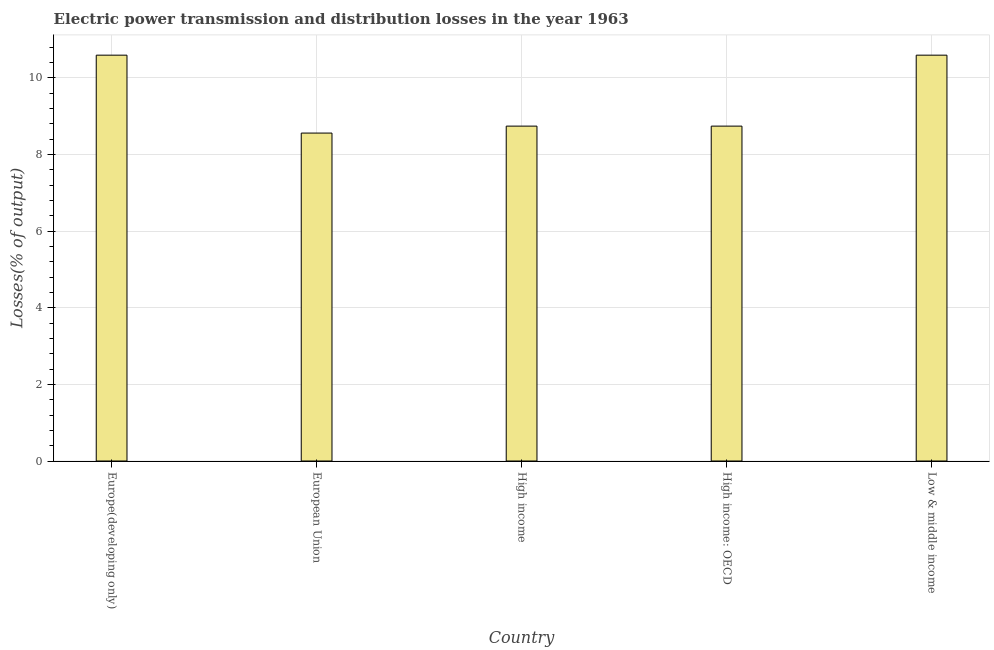Does the graph contain any zero values?
Your answer should be very brief. No. What is the title of the graph?
Provide a short and direct response. Electric power transmission and distribution losses in the year 1963. What is the label or title of the X-axis?
Offer a terse response. Country. What is the label or title of the Y-axis?
Your response must be concise. Losses(% of output). What is the electric power transmission and distribution losses in Low & middle income?
Provide a short and direct response. 10.6. Across all countries, what is the maximum electric power transmission and distribution losses?
Make the answer very short. 10.6. Across all countries, what is the minimum electric power transmission and distribution losses?
Keep it short and to the point. 8.56. In which country was the electric power transmission and distribution losses maximum?
Offer a terse response. Europe(developing only). In which country was the electric power transmission and distribution losses minimum?
Provide a succinct answer. European Union. What is the sum of the electric power transmission and distribution losses?
Keep it short and to the point. 47.24. What is the difference between the electric power transmission and distribution losses in Europe(developing only) and European Union?
Provide a short and direct response. 2.03. What is the average electric power transmission and distribution losses per country?
Provide a succinct answer. 9.45. What is the median electric power transmission and distribution losses?
Provide a short and direct response. 8.74. What is the ratio of the electric power transmission and distribution losses in Europe(developing only) to that in European Union?
Your answer should be very brief. 1.24. What is the difference between the highest and the second highest electric power transmission and distribution losses?
Keep it short and to the point. 0. Is the sum of the electric power transmission and distribution losses in European Union and Low & middle income greater than the maximum electric power transmission and distribution losses across all countries?
Provide a short and direct response. Yes. What is the difference between the highest and the lowest electric power transmission and distribution losses?
Offer a very short reply. 2.03. In how many countries, is the electric power transmission and distribution losses greater than the average electric power transmission and distribution losses taken over all countries?
Your response must be concise. 2. What is the difference between two consecutive major ticks on the Y-axis?
Offer a terse response. 2. What is the Losses(% of output) in Europe(developing only)?
Make the answer very short. 10.6. What is the Losses(% of output) of European Union?
Your response must be concise. 8.56. What is the Losses(% of output) of High income?
Make the answer very short. 8.74. What is the Losses(% of output) of High income: OECD?
Give a very brief answer. 8.74. What is the Losses(% of output) of Low & middle income?
Provide a succinct answer. 10.6. What is the difference between the Losses(% of output) in Europe(developing only) and European Union?
Your answer should be very brief. 2.03. What is the difference between the Losses(% of output) in Europe(developing only) and High income?
Give a very brief answer. 1.85. What is the difference between the Losses(% of output) in Europe(developing only) and High income: OECD?
Your response must be concise. 1.85. What is the difference between the Losses(% of output) in European Union and High income?
Your answer should be compact. -0.18. What is the difference between the Losses(% of output) in European Union and High income: OECD?
Your answer should be compact. -0.18. What is the difference between the Losses(% of output) in European Union and Low & middle income?
Your answer should be compact. -2.03. What is the difference between the Losses(% of output) in High income and High income: OECD?
Make the answer very short. 0. What is the difference between the Losses(% of output) in High income and Low & middle income?
Give a very brief answer. -1.85. What is the difference between the Losses(% of output) in High income: OECD and Low & middle income?
Offer a terse response. -1.85. What is the ratio of the Losses(% of output) in Europe(developing only) to that in European Union?
Give a very brief answer. 1.24. What is the ratio of the Losses(% of output) in Europe(developing only) to that in High income?
Keep it short and to the point. 1.21. What is the ratio of the Losses(% of output) in Europe(developing only) to that in High income: OECD?
Provide a short and direct response. 1.21. What is the ratio of the Losses(% of output) in European Union to that in High income: OECD?
Your answer should be compact. 0.98. What is the ratio of the Losses(% of output) in European Union to that in Low & middle income?
Your response must be concise. 0.81. What is the ratio of the Losses(% of output) in High income to that in High income: OECD?
Your answer should be very brief. 1. What is the ratio of the Losses(% of output) in High income to that in Low & middle income?
Keep it short and to the point. 0.82. What is the ratio of the Losses(% of output) in High income: OECD to that in Low & middle income?
Your response must be concise. 0.82. 